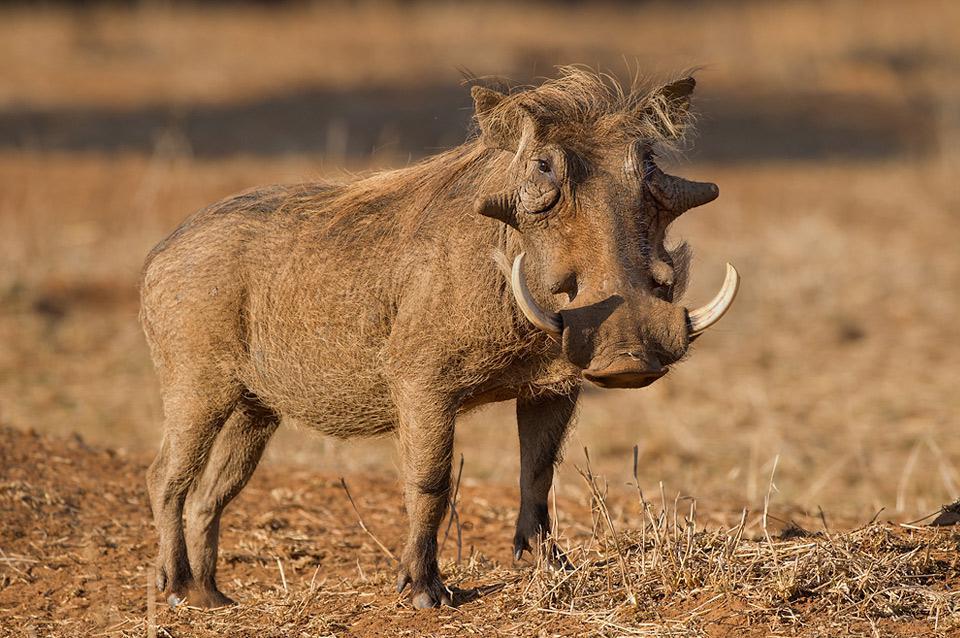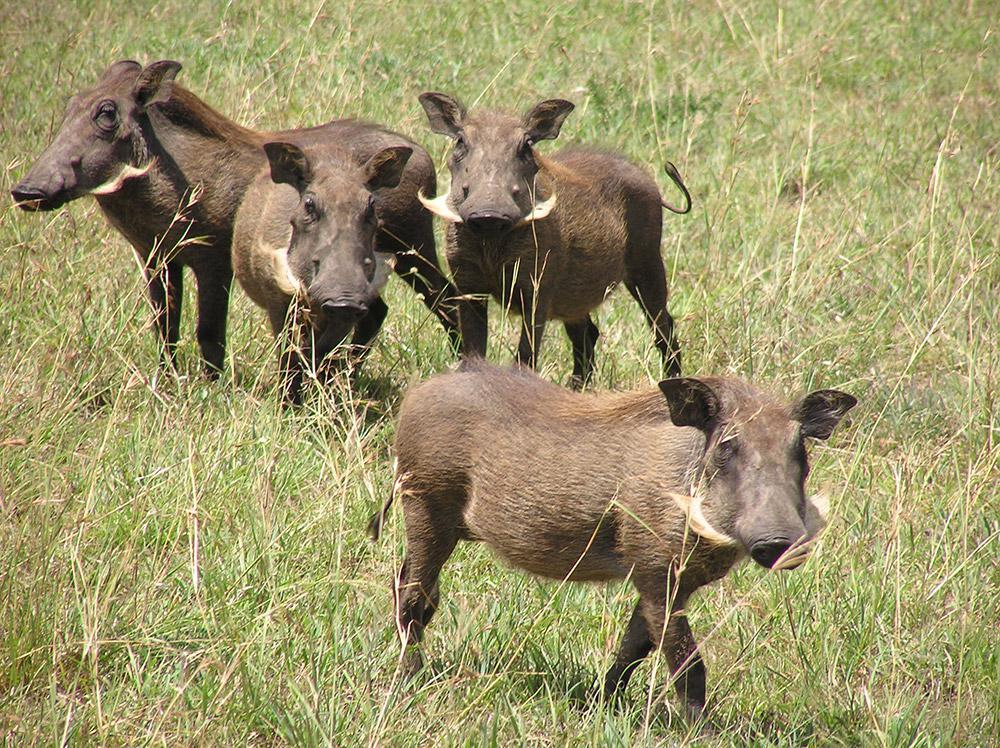The first image is the image on the left, the second image is the image on the right. Assess this claim about the two images: "An image shows at least one mammal behind the hog in the foreground.". Correct or not? Answer yes or no. Yes. 